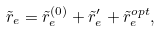Convert formula to latex. <formula><loc_0><loc_0><loc_500><loc_500>\tilde { r } _ { e } = \tilde { r } _ { e } ^ { ( 0 ) } + \tilde { r } _ { e } ^ { \prime } + \tilde { r } _ { e } ^ { o p t } ,</formula> 